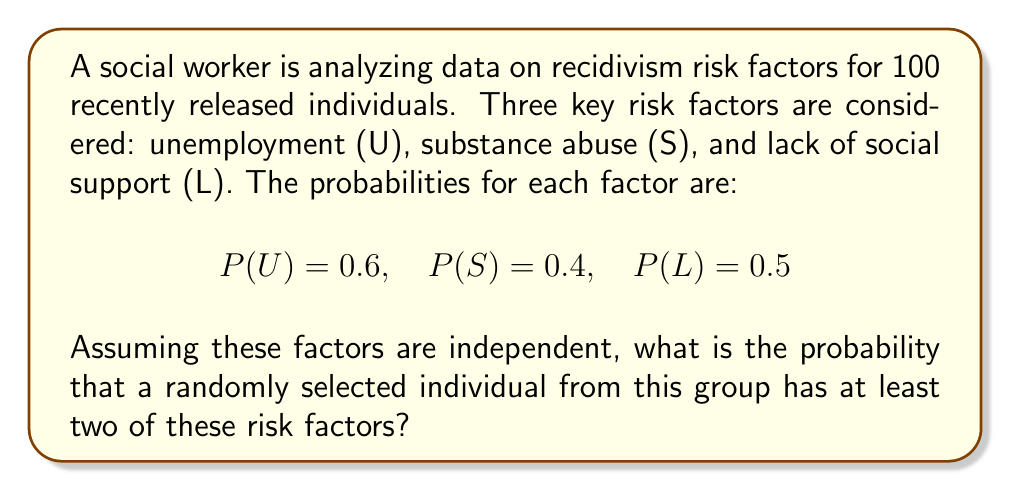Help me with this question. To solve this problem, we'll use the concept of complementary events and the inclusion-exclusion principle.

Step 1: Calculate the probability of having none or only one risk factor.

P(no risk factors) = P(not U and not S and not L)
$$ = (1-0.6) \times (1-0.4) \times (1-0.5) = 0.4 \times 0.6 \times 0.5 = 0.12 $$

P(only U) = $0.6 \times (1-0.4) \times (1-0.5) = 0.6 \times 0.6 \times 0.5 = 0.18$
P(only S) = $(1-0.6) \times 0.4 \times (1-0.5) = 0.4 \times 0.4 \times 0.5 = 0.08$
P(only L) = $(1-0.6) \times (1-0.4) \times 0.5 = 0.4 \times 0.6 \times 0.5 = 0.12$

P(exactly one risk factor) = $0.18 + 0.08 + 0.12 = 0.38$

Step 2: Calculate the probability of having at least two risk factors.

P(at least two risk factors) = 1 - P(no risk factors) - P(exactly one risk factor)
$$ = 1 - 0.12 - 0.38 = 0.50 $$

Therefore, the probability that a randomly selected individual has at least two of these risk factors is 0.50 or 50%.
Answer: 0.50 